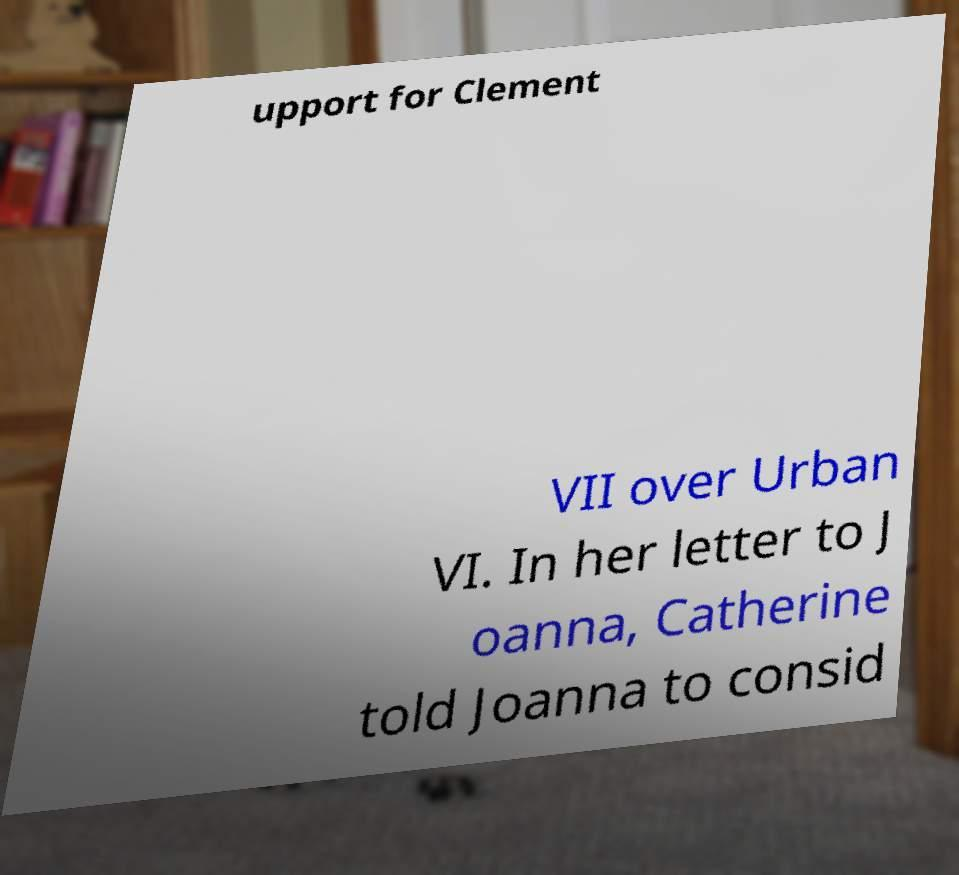Please identify and transcribe the text found in this image. upport for Clement VII over Urban VI. In her letter to J oanna, Catherine told Joanna to consid 